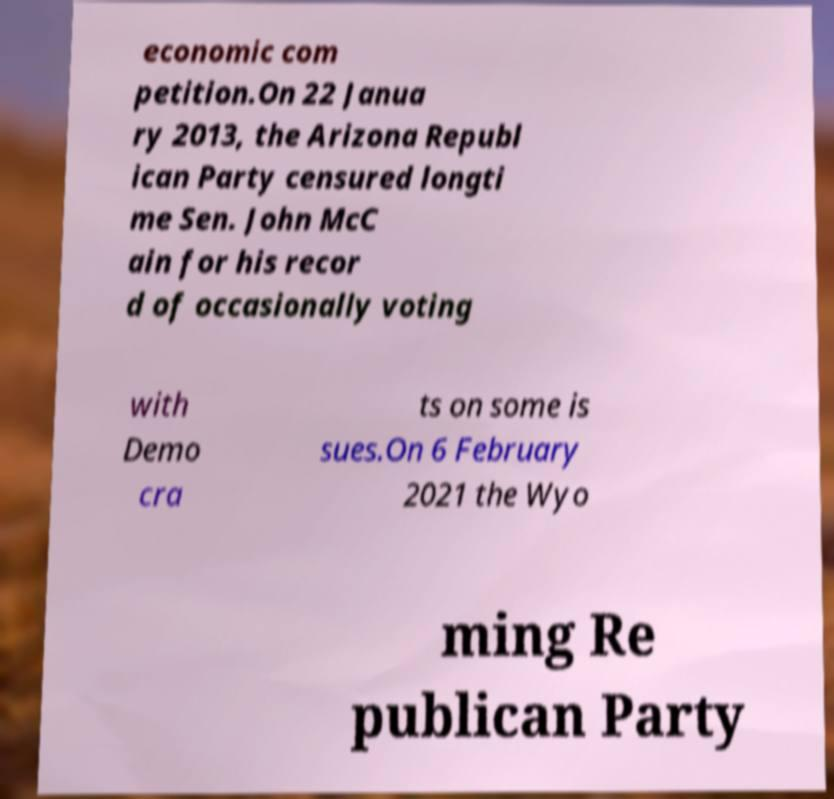Could you extract and type out the text from this image? economic com petition.On 22 Janua ry 2013, the Arizona Republ ican Party censured longti me Sen. John McC ain for his recor d of occasionally voting with Demo cra ts on some is sues.On 6 February 2021 the Wyo ming Re publican Party 